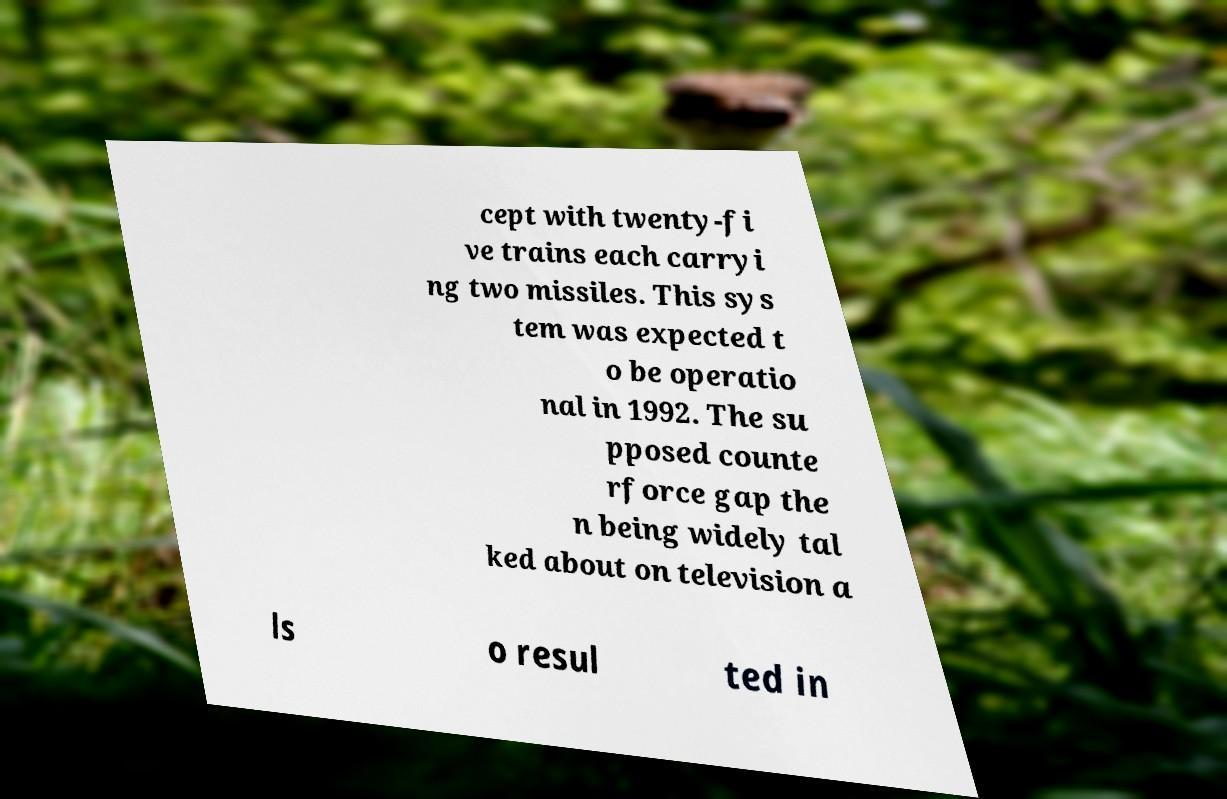I need the written content from this picture converted into text. Can you do that? cept with twenty-fi ve trains each carryi ng two missiles. This sys tem was expected t o be operatio nal in 1992. The su pposed counte rforce gap the n being widely tal ked about on television a ls o resul ted in 